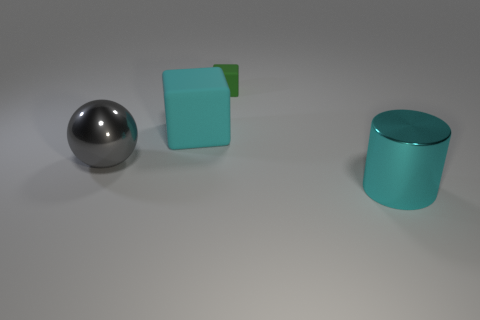Add 2 small cyan shiny spheres. How many objects exist? 6 Subtract all balls. How many objects are left? 3 Add 3 metal spheres. How many metal spheres exist? 4 Subtract 0 red cubes. How many objects are left? 4 Subtract all gray cubes. Subtract all green cylinders. How many cubes are left? 2 Subtract all big cyan matte cylinders. Subtract all tiny things. How many objects are left? 3 Add 4 gray shiny spheres. How many gray shiny spheres are left? 5 